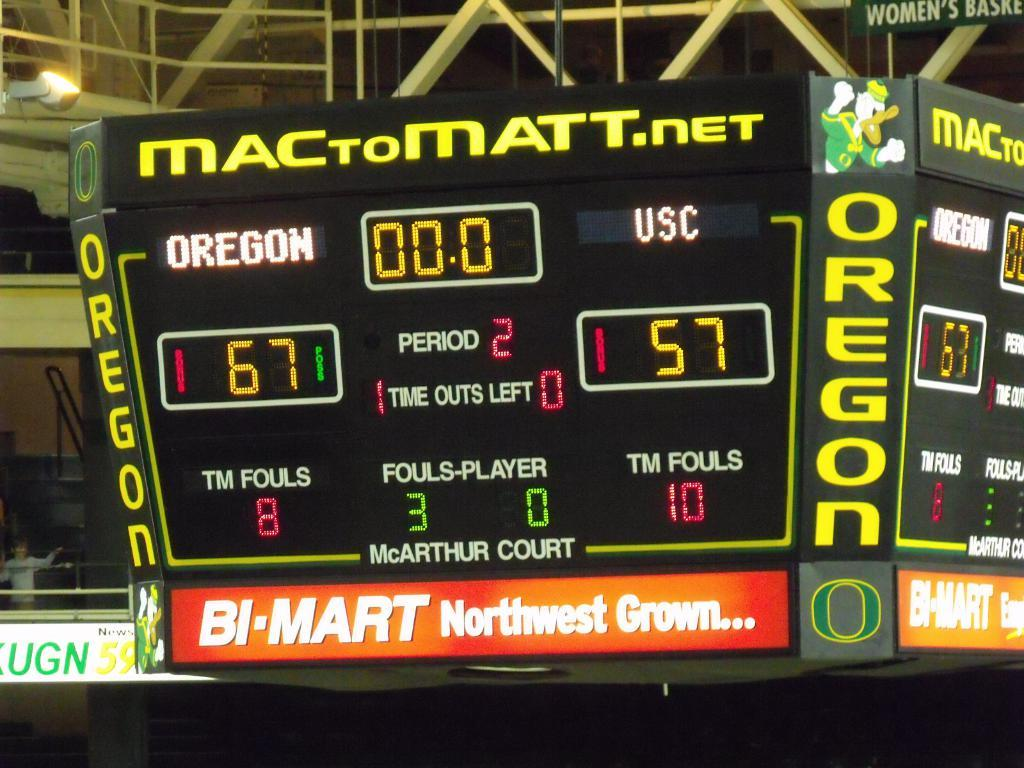<image>
Summarize the visual content of the image. A large scoreboard shows that Oregon is beating USC, with a score of 67 to 57. 